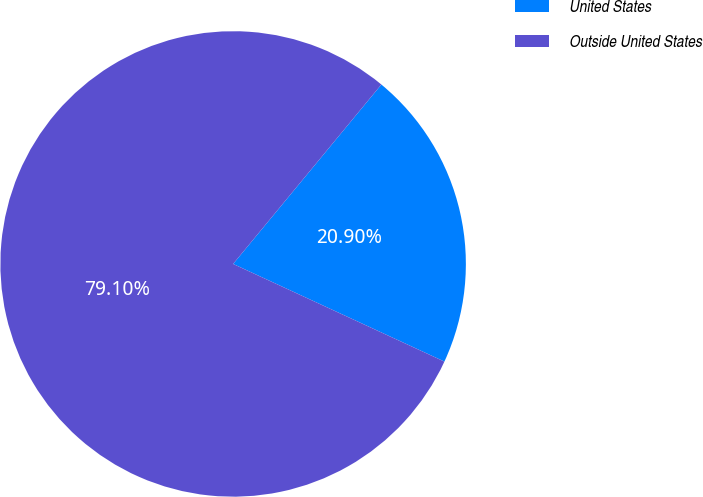Convert chart to OTSL. <chart><loc_0><loc_0><loc_500><loc_500><pie_chart><fcel>United States<fcel>Outside United States<nl><fcel>20.9%<fcel>79.1%<nl></chart> 